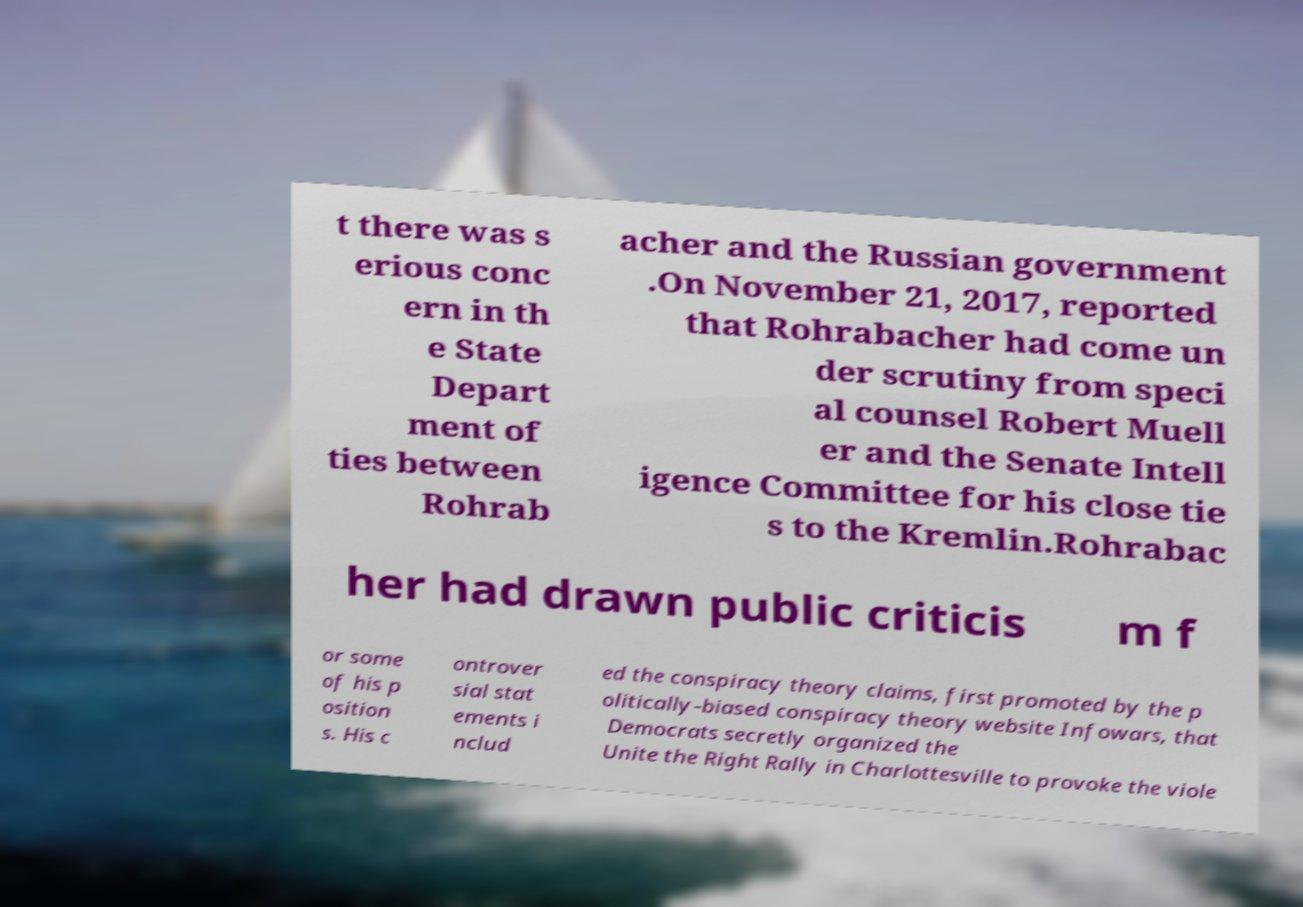What messages or text are displayed in this image? I need them in a readable, typed format. t there was s erious conc ern in th e State Depart ment of ties between Rohrab acher and the Russian government .On November 21, 2017, reported that Rohrabacher had come un der scrutiny from speci al counsel Robert Muell er and the Senate Intell igence Committee for his close tie s to the Kremlin.Rohrabac her had drawn public criticis m f or some of his p osition s. His c ontrover sial stat ements i nclud ed the conspiracy theory claims, first promoted by the p olitically-biased conspiracy theory website Infowars, that Democrats secretly organized the Unite the Right Rally in Charlottesville to provoke the viole 